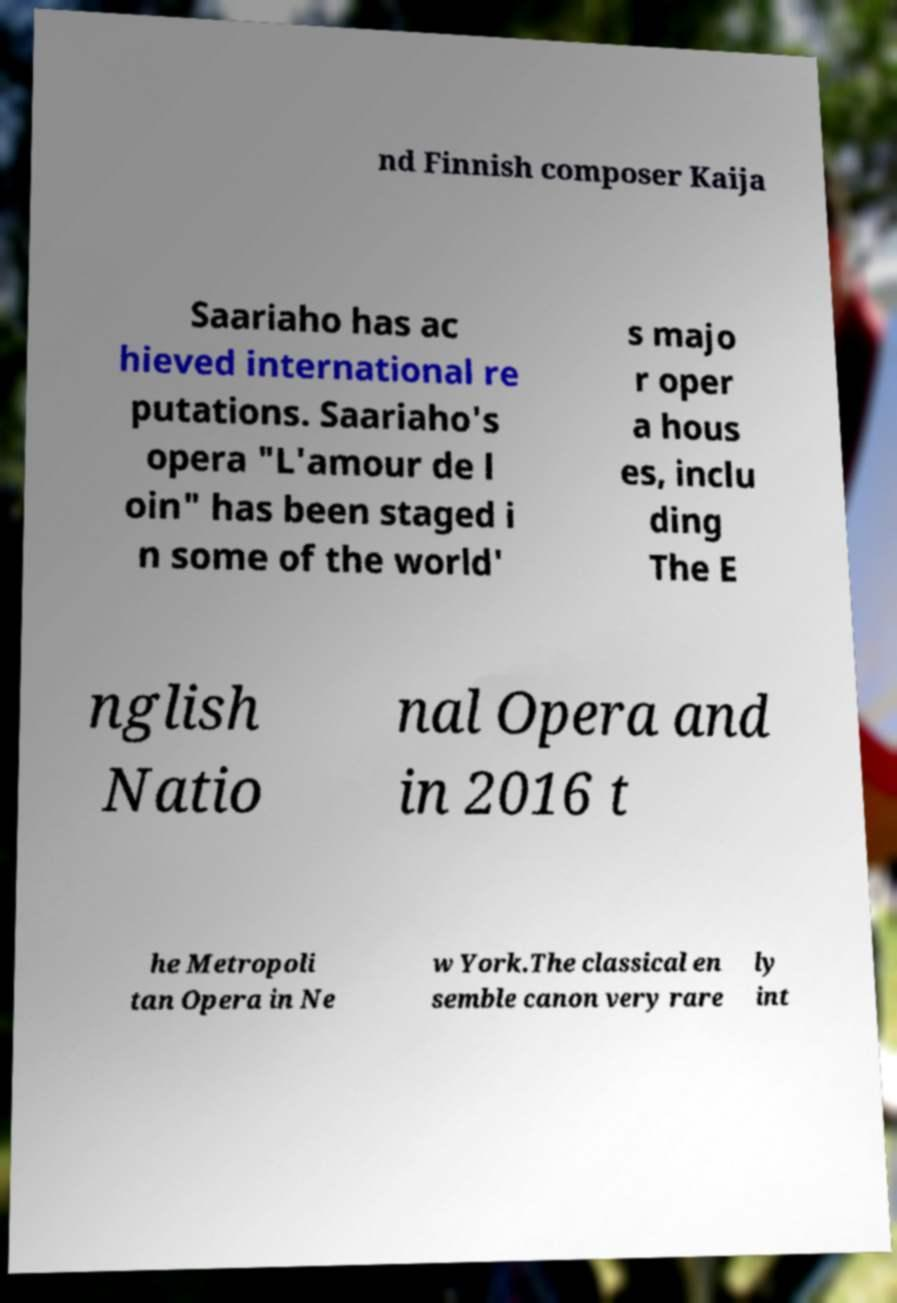What messages or text are displayed in this image? I need them in a readable, typed format. nd Finnish composer Kaija Saariaho has ac hieved international re putations. Saariaho's opera "L'amour de l oin" has been staged i n some of the world' s majo r oper a hous es, inclu ding The E nglish Natio nal Opera and in 2016 t he Metropoli tan Opera in Ne w York.The classical en semble canon very rare ly int 